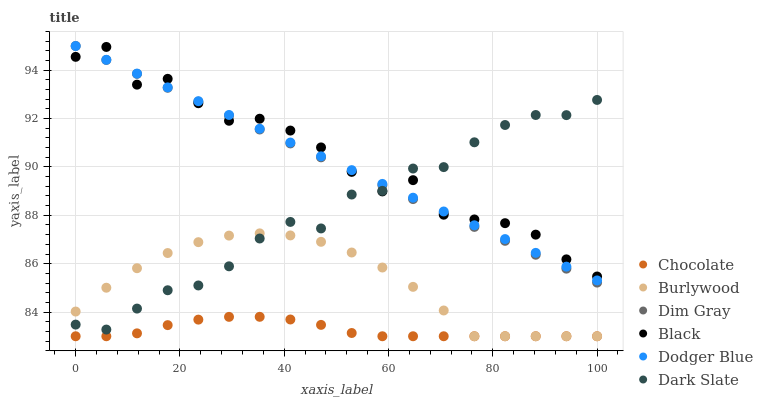Does Chocolate have the minimum area under the curve?
Answer yes or no. Yes. Does Black have the maximum area under the curve?
Answer yes or no. Yes. Does Burlywood have the minimum area under the curve?
Answer yes or no. No. Does Burlywood have the maximum area under the curve?
Answer yes or no. No. Is Dim Gray the smoothest?
Answer yes or no. Yes. Is Black the roughest?
Answer yes or no. Yes. Is Burlywood the smoothest?
Answer yes or no. No. Is Burlywood the roughest?
Answer yes or no. No. Does Burlywood have the lowest value?
Answer yes or no. Yes. Does Dark Slate have the lowest value?
Answer yes or no. No. Does Dodger Blue have the highest value?
Answer yes or no. Yes. Does Burlywood have the highest value?
Answer yes or no. No. Is Chocolate less than Dark Slate?
Answer yes or no. Yes. Is Dodger Blue greater than Chocolate?
Answer yes or no. Yes. Does Dark Slate intersect Dodger Blue?
Answer yes or no. Yes. Is Dark Slate less than Dodger Blue?
Answer yes or no. No. Is Dark Slate greater than Dodger Blue?
Answer yes or no. No. Does Chocolate intersect Dark Slate?
Answer yes or no. No. 